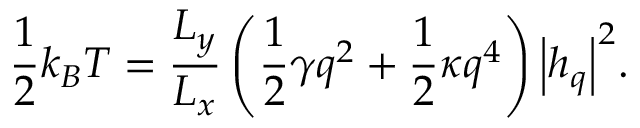Convert formula to latex. <formula><loc_0><loc_0><loc_500><loc_500>\frac { 1 } { 2 } { { k } _ { B } } T = \frac { { { L } _ { y } } } { { { L } _ { x } } } \left ( \frac { 1 } { 2 } \gamma { { q } ^ { 2 } } + \frac { 1 } { 2 } \kappa { { q } ^ { 4 } } \right ) { { \left | h _ { q } \right | } ^ { 2 } } .</formula> 